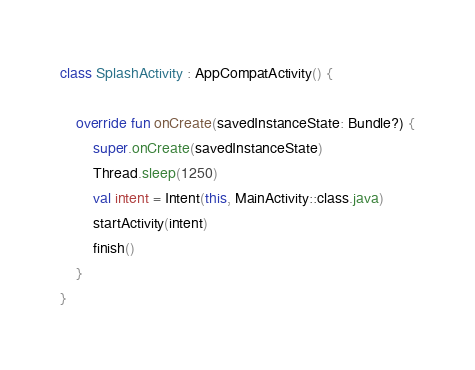Convert code to text. <code><loc_0><loc_0><loc_500><loc_500><_Kotlin_>

class SplashActivity : AppCompatActivity() {

    override fun onCreate(savedInstanceState: Bundle?) {
        super.onCreate(savedInstanceState)
        Thread.sleep(1250)
        val intent = Intent(this, MainActivity::class.java)
        startActivity(intent)
        finish()
    }
}</code> 